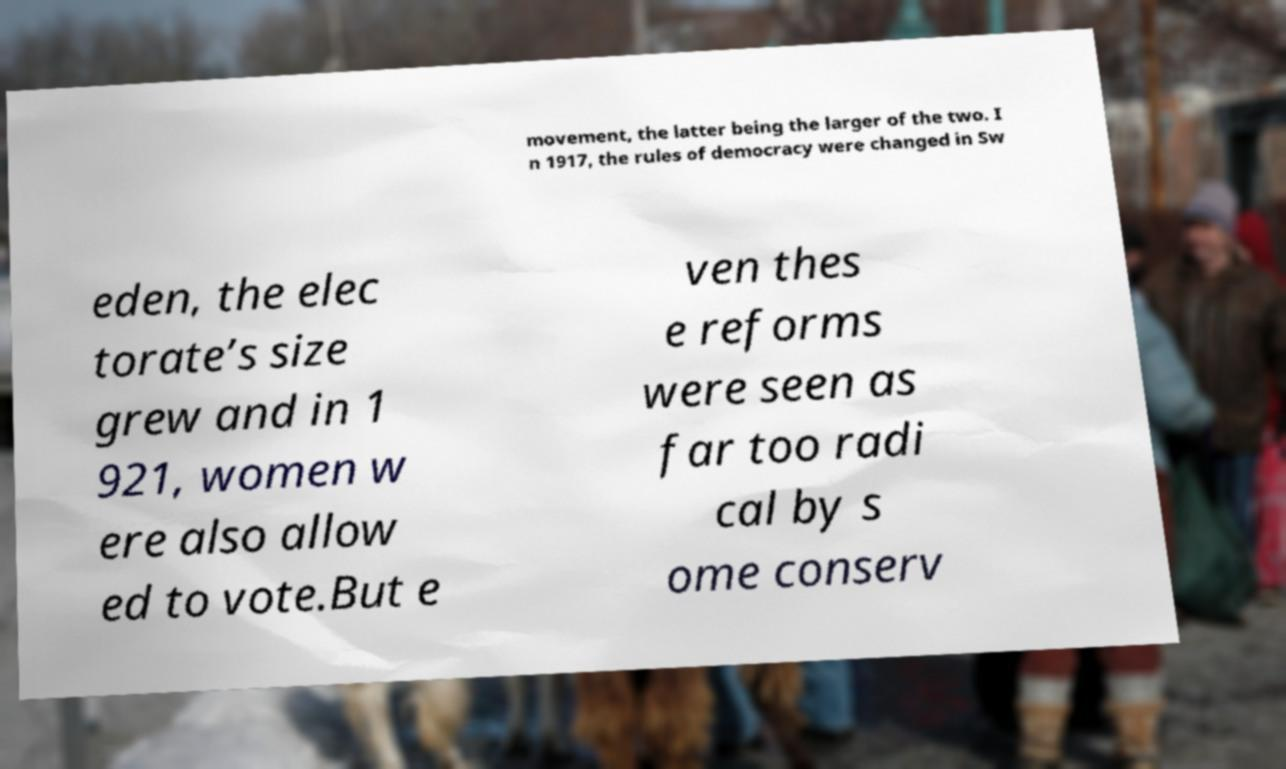Could you assist in decoding the text presented in this image and type it out clearly? movement, the latter being the larger of the two. I n 1917, the rules of democracy were changed in Sw eden, the elec torate’s size grew and in 1 921, women w ere also allow ed to vote.But e ven thes e reforms were seen as far too radi cal by s ome conserv 